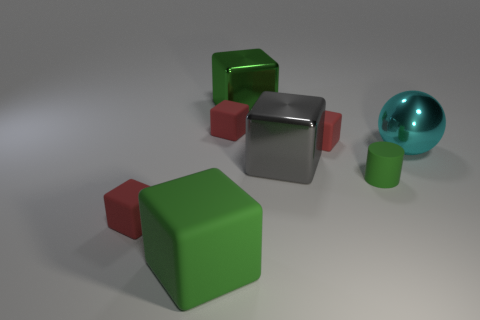Subtract all yellow balls. How many red cubes are left? 3 Subtract all gray cubes. How many cubes are left? 5 Subtract all gray blocks. How many blocks are left? 5 Subtract all brown blocks. Subtract all purple cylinders. How many blocks are left? 6 Add 1 big gray shiny spheres. How many objects exist? 9 Subtract all blocks. How many objects are left? 2 Subtract 0 blue balls. How many objects are left? 8 Subtract all red matte objects. Subtract all large green matte things. How many objects are left? 4 Add 5 green rubber cylinders. How many green rubber cylinders are left? 6 Add 1 large yellow shiny things. How many large yellow shiny things exist? 1 